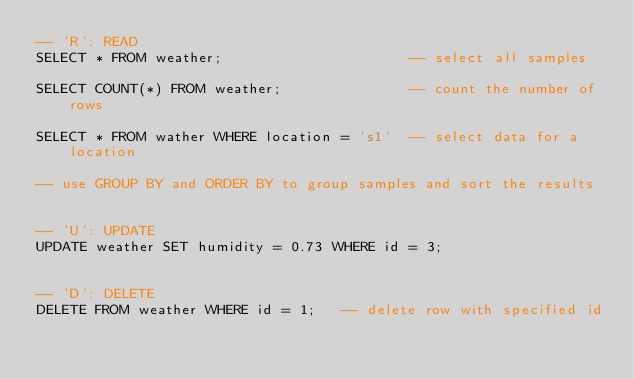<code> <loc_0><loc_0><loc_500><loc_500><_SQL_>-- 'R': READ
SELECT * FROM weather;                      -- select all samples

SELECT COUNT(*) FROM weather;               -- count the number of rows

SELECT * FROM wather WHERE location = 's1'  -- select data for a location

-- use GROUP BY and ORDER BY to group samples and sort the results


-- 'U': UPDATE
UPDATE weather SET humidity = 0.73 WHERE id = 3;


-- 'D': DELETE
DELETE FROM weather WHERE id = 1;   -- delete row with specified id


</code> 